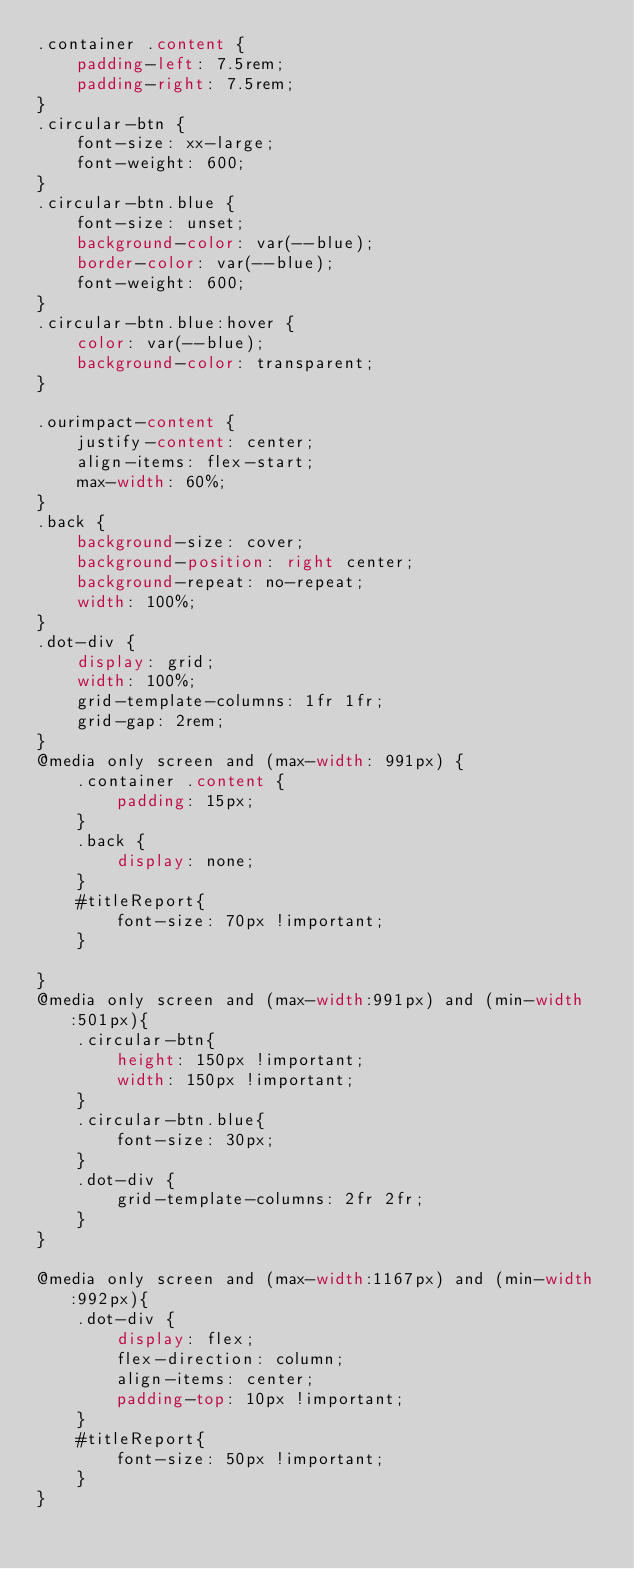Convert code to text. <code><loc_0><loc_0><loc_500><loc_500><_CSS_>.container .content {
    padding-left: 7.5rem;
    padding-right: 7.5rem;
}
.circular-btn {
    font-size: xx-large;
    font-weight: 600;
}
.circular-btn.blue {
    font-size: unset;
    background-color: var(--blue);
    border-color: var(--blue);
    font-weight: 600;
}
.circular-btn.blue:hover {
    color: var(--blue);
    background-color: transparent;
}

.ourimpact-content {
    justify-content: center;
    align-items: flex-start;
    max-width: 60%;
}
.back {
    background-size: cover;
    background-position: right center;
    background-repeat: no-repeat;
    width: 100%;
}
.dot-div {
    display: grid;
    width: 100%;
    grid-template-columns: 1fr 1fr;
    grid-gap: 2rem;
}
@media only screen and (max-width: 991px) {
    .container .content {
        padding: 15px;
    }
    .back {
        display: none;
    }
    #titleReport{
        font-size: 70px !important;
    }
    
}
@media only screen and (max-width:991px) and (min-width:501px){
    .circular-btn{
        height: 150px !important;
        width: 150px !important;
    }
    .circular-btn.blue{
        font-size: 30px;
    }
    .dot-div {     
        grid-template-columns: 2fr 2fr;      
    }
}

@media only screen and (max-width:1167px) and (min-width:992px){
    .dot-div {
        display: flex;
        flex-direction: column;
        align-items: center;
        padding-top: 10px !important;
    }
    #titleReport{
        font-size: 50px !important;
    }
}
</code> 